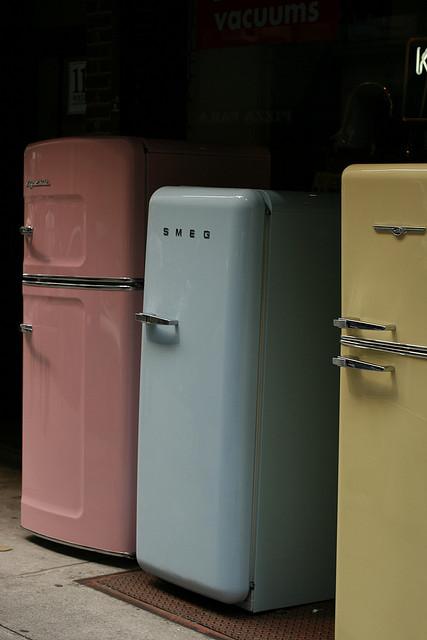Are there bodies hidden in the fridges?
Quick response, please. No. Are all fridges the same size?
Answer briefly. No. What color is the middle fridge?
Quick response, please. White. What color is the fridge door?
Concise answer only. Blue. Is this part of a computer?
Quick response, please. No. 